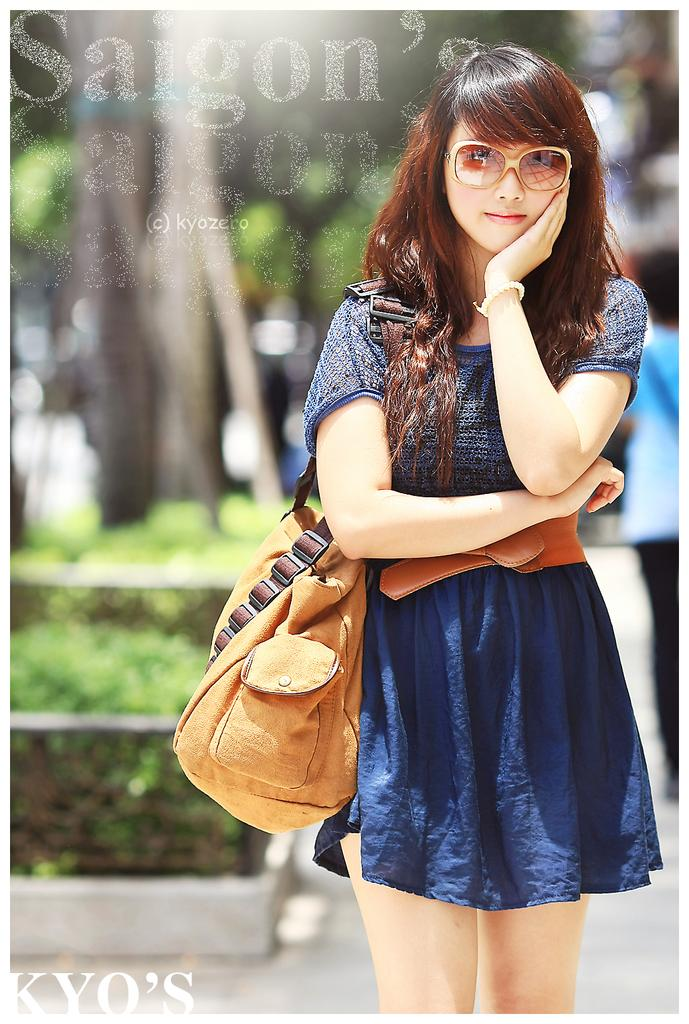Who is the main subject in the image? There is a girl in the image. Where is the girl positioned in the image? The girl is standing on the right side of the image. What is the girl wearing in the image? The girl is wearing a brown handbag. What can be seen in the background of the image? There are trees around the area of the image. How many ladybugs are on the girl's handbag in the image? There are no ladybugs visible on the girl's handbag in the image. What shape is the heart that the girl is holding in the image? There is no heart present in the image for the girl to hold. 